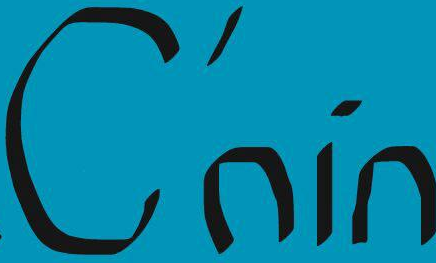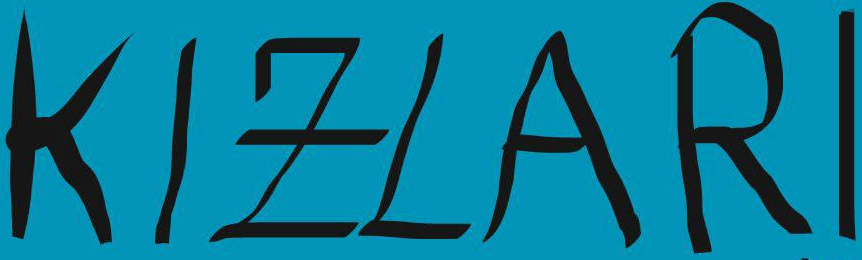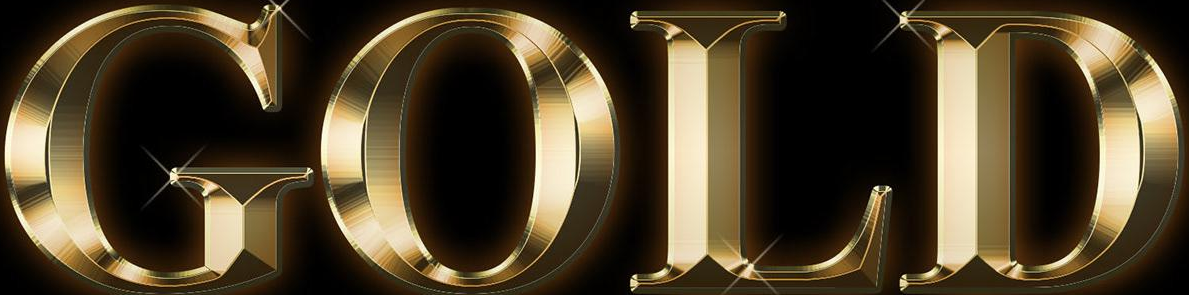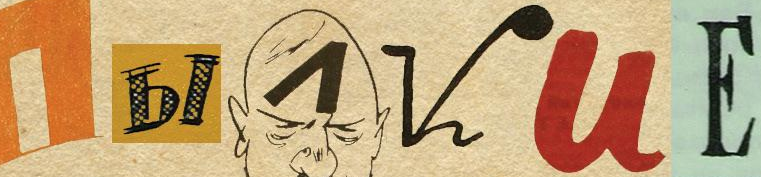What words can you see in these images in sequence, separated by a semicolon? C'nin; KIZLARI; GOLD; I##VUЕ 